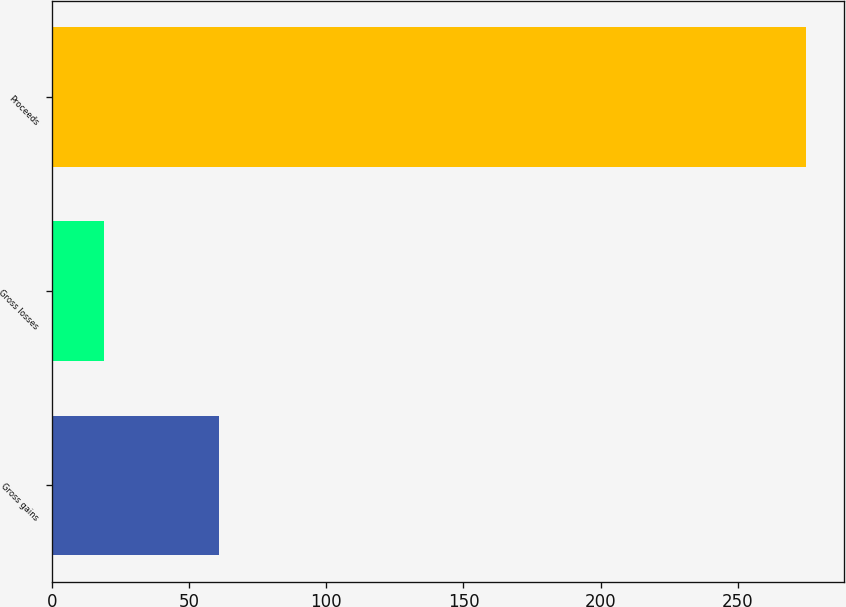<chart> <loc_0><loc_0><loc_500><loc_500><bar_chart><fcel>Gross gains<fcel>Gross losses<fcel>Proceeds<nl><fcel>61<fcel>19<fcel>275<nl></chart> 